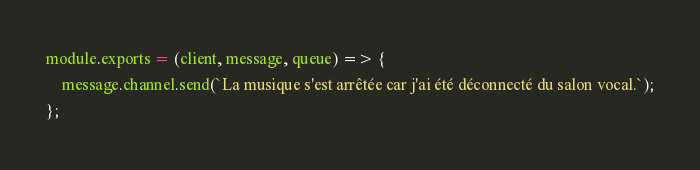Convert code to text. <code><loc_0><loc_0><loc_500><loc_500><_JavaScript_>module.exports = (client, message, queue) => {
    message.channel.send(`La musique s'est arrêtée car j'ai été déconnecté du salon vocal.`);
};</code> 